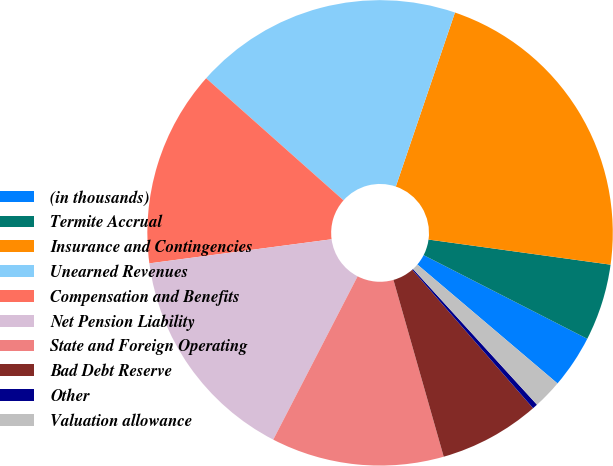Convert chart. <chart><loc_0><loc_0><loc_500><loc_500><pie_chart><fcel>(in thousands)<fcel>Termite Accrual<fcel>Insurance and Contingencies<fcel>Unearned Revenues<fcel>Compensation and Benefits<fcel>Net Pension Liability<fcel>State and Foreign Operating<fcel>Bad Debt Reserve<fcel>Other<fcel>Valuation allowance<nl><fcel>3.68%<fcel>5.34%<fcel>21.97%<fcel>18.65%<fcel>13.66%<fcel>15.32%<fcel>12.0%<fcel>7.01%<fcel>0.36%<fcel>2.02%<nl></chart> 